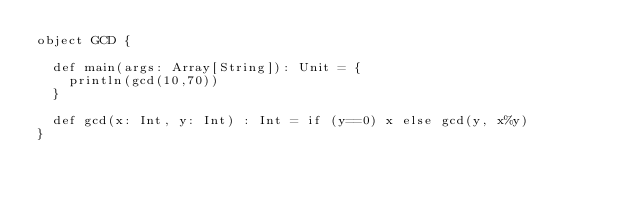<code> <loc_0><loc_0><loc_500><loc_500><_Scala_>object GCD {

  def main(args: Array[String]): Unit = {
    println(gcd(10,70))
  }

  def gcd(x: Int, y: Int) : Int = if (y==0) x else gcd(y, x%y)
}</code> 